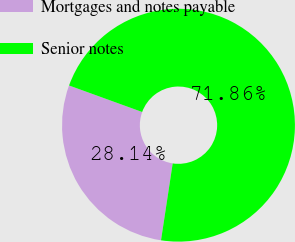Convert chart to OTSL. <chart><loc_0><loc_0><loc_500><loc_500><pie_chart><fcel>Mortgages and notes payable<fcel>Senior notes<nl><fcel>28.14%<fcel>71.86%<nl></chart> 